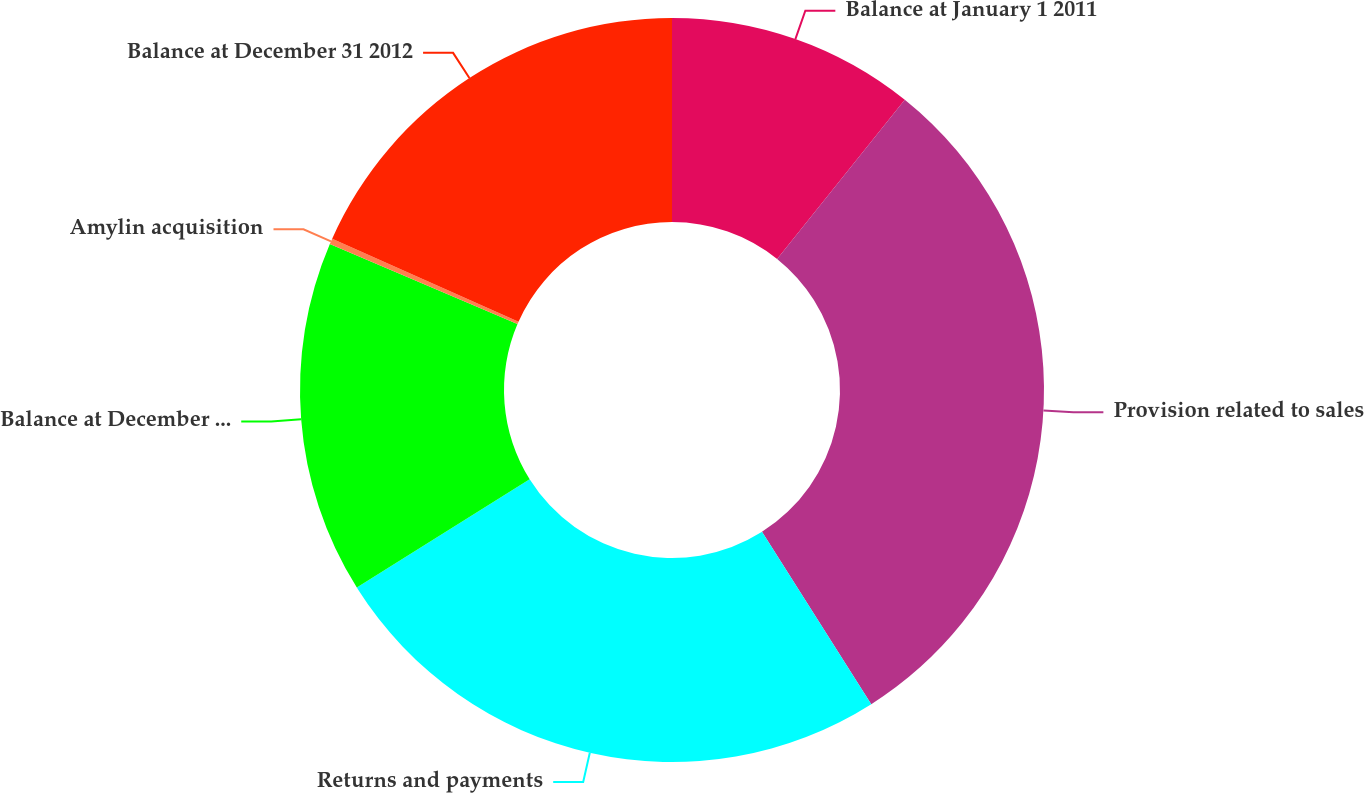<chart> <loc_0><loc_0><loc_500><loc_500><pie_chart><fcel>Balance at January 1 2011<fcel>Provision related to sales<fcel>Returns and payments<fcel>Balance at December 31 2011<fcel>Amylin acquisition<fcel>Balance at December 31 2012<nl><fcel>10.76%<fcel>30.24%<fcel>25.08%<fcel>15.33%<fcel>0.25%<fcel>18.33%<nl></chart> 